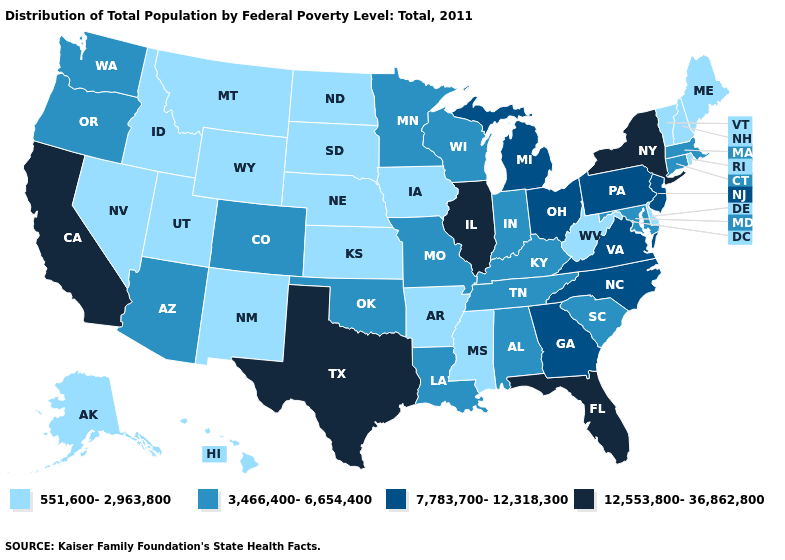Name the states that have a value in the range 7,783,700-12,318,300?
Answer briefly. Georgia, Michigan, New Jersey, North Carolina, Ohio, Pennsylvania, Virginia. What is the value of Connecticut?
Answer briefly. 3,466,400-6,654,400. Does New Mexico have the lowest value in the USA?
Write a very short answer. Yes. What is the value of Kansas?
Be succinct. 551,600-2,963,800. Does the first symbol in the legend represent the smallest category?
Short answer required. Yes. What is the value of Idaho?
Concise answer only. 551,600-2,963,800. What is the value of Georgia?
Give a very brief answer. 7,783,700-12,318,300. Is the legend a continuous bar?
Answer briefly. No. How many symbols are there in the legend?
Write a very short answer. 4. Among the states that border Tennessee , which have the lowest value?
Be succinct. Arkansas, Mississippi. Among the states that border Colorado , which have the lowest value?
Be succinct. Kansas, Nebraska, New Mexico, Utah, Wyoming. Name the states that have a value in the range 551,600-2,963,800?
Concise answer only. Alaska, Arkansas, Delaware, Hawaii, Idaho, Iowa, Kansas, Maine, Mississippi, Montana, Nebraska, Nevada, New Hampshire, New Mexico, North Dakota, Rhode Island, South Dakota, Utah, Vermont, West Virginia, Wyoming. What is the value of Oklahoma?
Write a very short answer. 3,466,400-6,654,400. Name the states that have a value in the range 551,600-2,963,800?
Short answer required. Alaska, Arkansas, Delaware, Hawaii, Idaho, Iowa, Kansas, Maine, Mississippi, Montana, Nebraska, Nevada, New Hampshire, New Mexico, North Dakota, Rhode Island, South Dakota, Utah, Vermont, West Virginia, Wyoming. What is the value of Illinois?
Concise answer only. 12,553,800-36,862,800. 